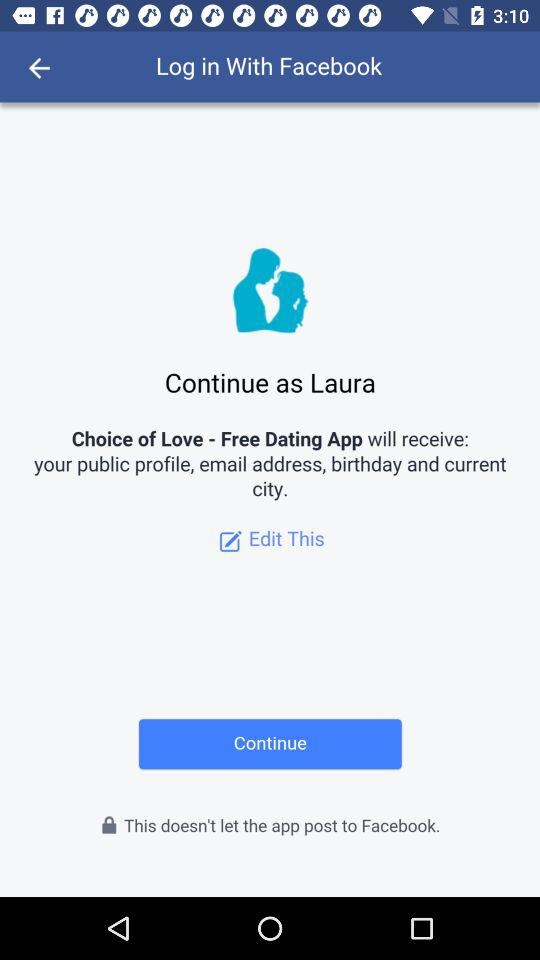What is the name of the user? The name of the user is Laura. 